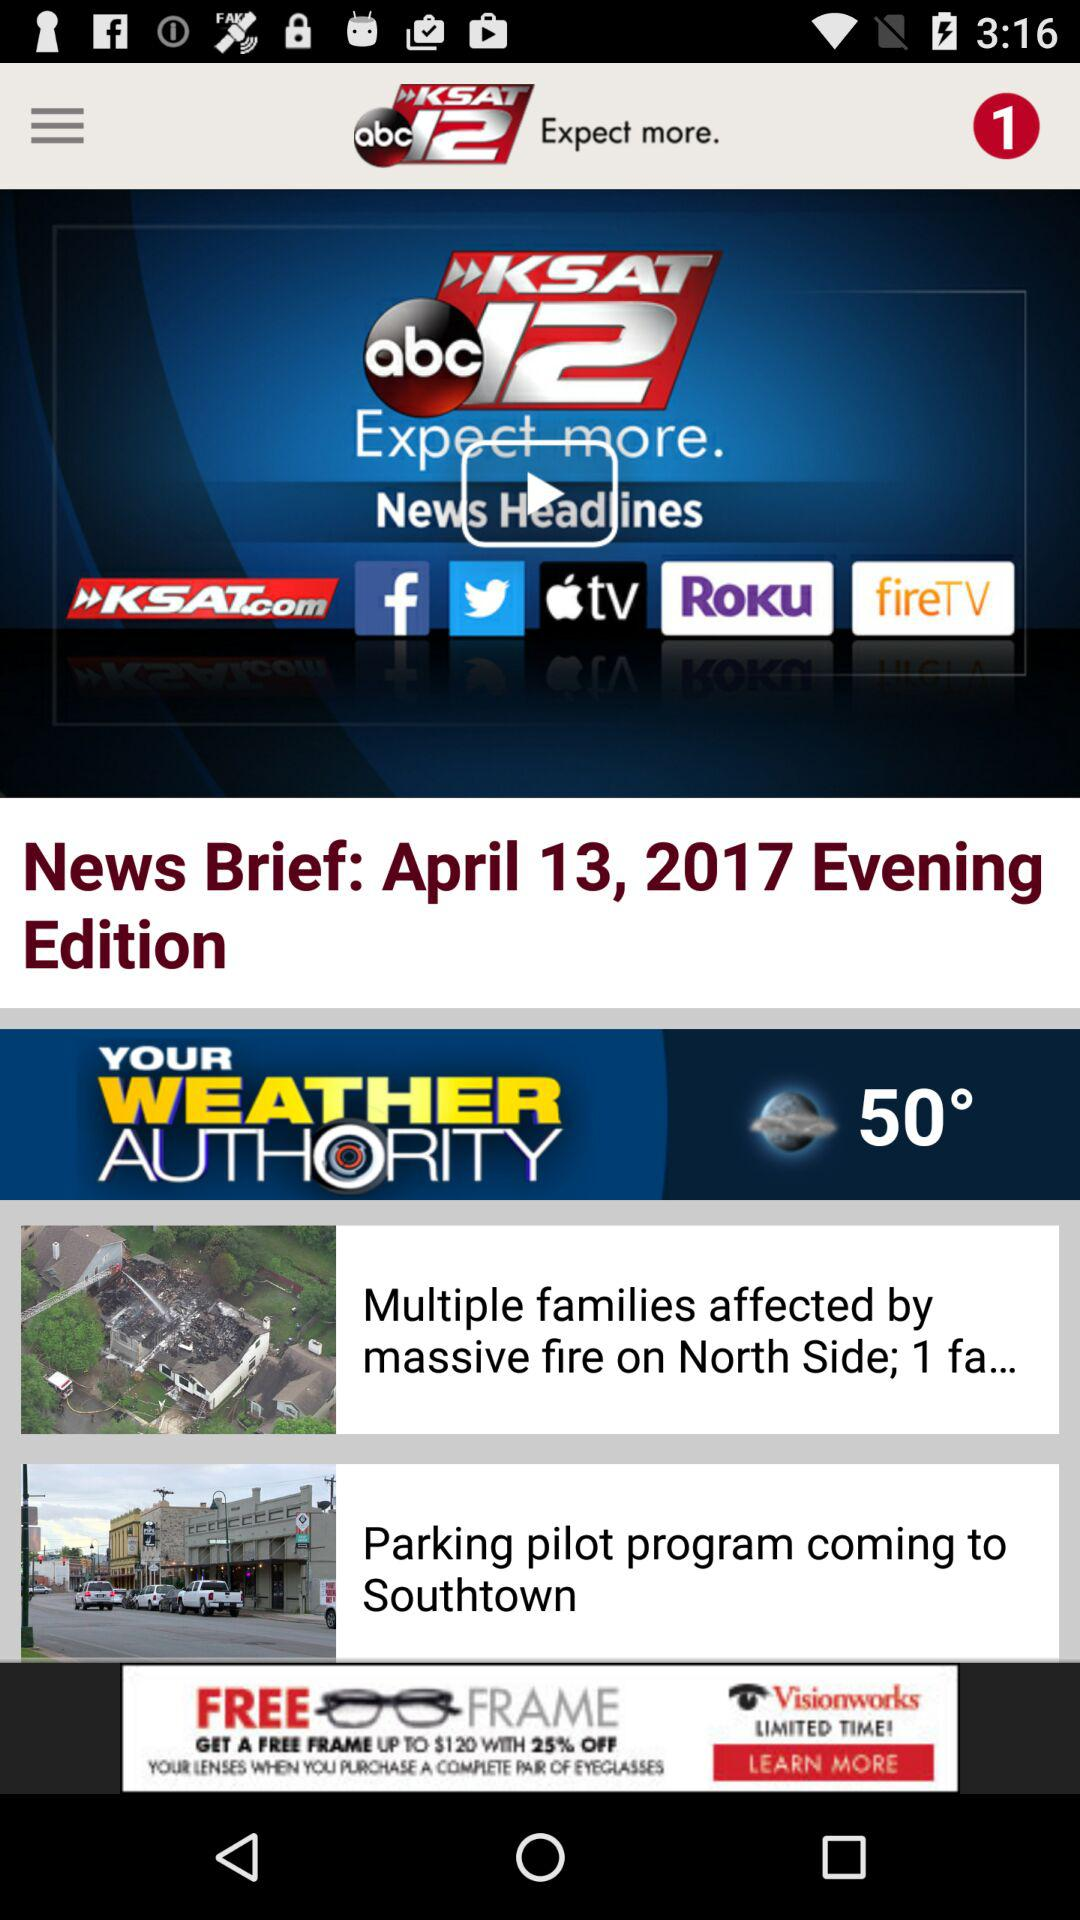What is the date? The date is April 13, 2017. 